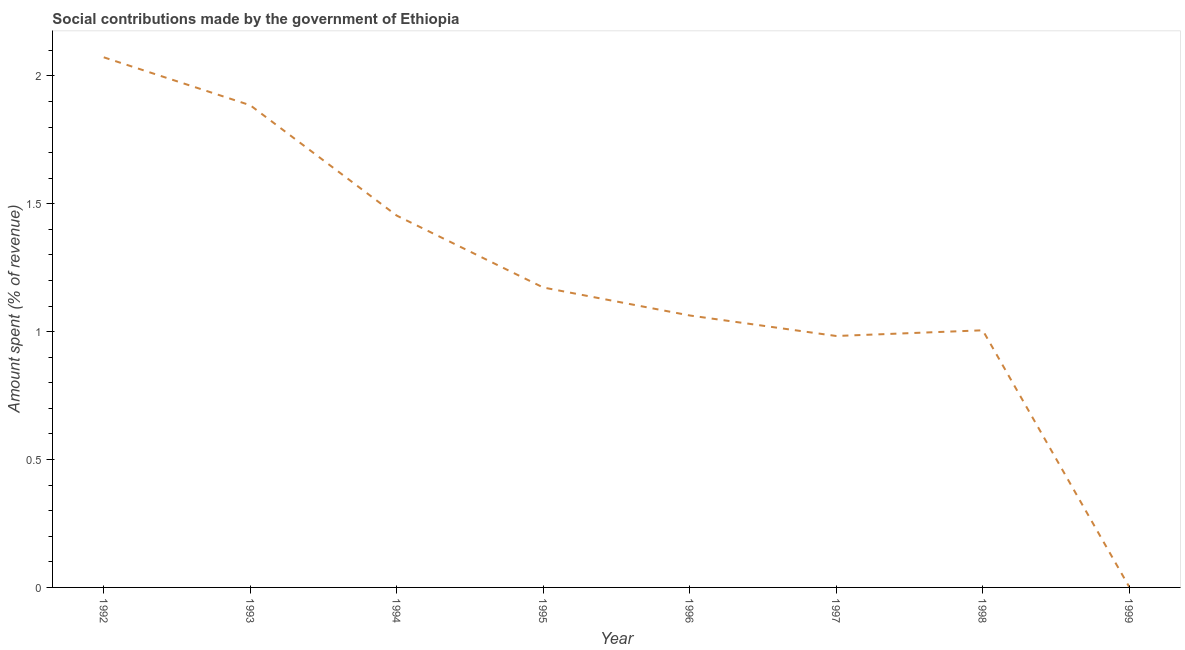What is the amount spent in making social contributions in 1993?
Offer a very short reply. 1.89. Across all years, what is the maximum amount spent in making social contributions?
Your response must be concise. 2.07. Across all years, what is the minimum amount spent in making social contributions?
Keep it short and to the point. 0. In which year was the amount spent in making social contributions minimum?
Make the answer very short. 1999. What is the sum of the amount spent in making social contributions?
Your response must be concise. 9.64. What is the difference between the amount spent in making social contributions in 1993 and 1999?
Your response must be concise. 1.88. What is the average amount spent in making social contributions per year?
Keep it short and to the point. 1.2. What is the median amount spent in making social contributions?
Your response must be concise. 1.12. Do a majority of the years between 1998 and 1995 (inclusive) have amount spent in making social contributions greater than 0.6 %?
Provide a succinct answer. Yes. What is the ratio of the amount spent in making social contributions in 1992 to that in 1993?
Ensure brevity in your answer.  1.1. Is the difference between the amount spent in making social contributions in 1992 and 1996 greater than the difference between any two years?
Ensure brevity in your answer.  No. What is the difference between the highest and the second highest amount spent in making social contributions?
Give a very brief answer. 0.19. Is the sum of the amount spent in making social contributions in 1992 and 1998 greater than the maximum amount spent in making social contributions across all years?
Keep it short and to the point. Yes. What is the difference between the highest and the lowest amount spent in making social contributions?
Offer a very short reply. 2.07. Does the amount spent in making social contributions monotonically increase over the years?
Keep it short and to the point. No. What is the difference between two consecutive major ticks on the Y-axis?
Provide a succinct answer. 0.5. Are the values on the major ticks of Y-axis written in scientific E-notation?
Offer a very short reply. No. Does the graph contain grids?
Your response must be concise. No. What is the title of the graph?
Your answer should be compact. Social contributions made by the government of Ethiopia. What is the label or title of the X-axis?
Give a very brief answer. Year. What is the label or title of the Y-axis?
Your answer should be compact. Amount spent (% of revenue). What is the Amount spent (% of revenue) in 1992?
Give a very brief answer. 2.07. What is the Amount spent (% of revenue) of 1993?
Provide a short and direct response. 1.89. What is the Amount spent (% of revenue) of 1994?
Your response must be concise. 1.45. What is the Amount spent (% of revenue) of 1995?
Your answer should be compact. 1.17. What is the Amount spent (% of revenue) of 1996?
Give a very brief answer. 1.06. What is the Amount spent (% of revenue) in 1997?
Ensure brevity in your answer.  0.98. What is the Amount spent (% of revenue) in 1998?
Offer a very short reply. 1.01. What is the Amount spent (% of revenue) of 1999?
Your response must be concise. 0. What is the difference between the Amount spent (% of revenue) in 1992 and 1993?
Your answer should be compact. 0.19. What is the difference between the Amount spent (% of revenue) in 1992 and 1994?
Offer a terse response. 0.62. What is the difference between the Amount spent (% of revenue) in 1992 and 1995?
Provide a succinct answer. 0.9. What is the difference between the Amount spent (% of revenue) in 1992 and 1996?
Your answer should be very brief. 1.01. What is the difference between the Amount spent (% of revenue) in 1992 and 1997?
Provide a succinct answer. 1.09. What is the difference between the Amount spent (% of revenue) in 1992 and 1998?
Offer a very short reply. 1.07. What is the difference between the Amount spent (% of revenue) in 1992 and 1999?
Your response must be concise. 2.07. What is the difference between the Amount spent (% of revenue) in 1993 and 1994?
Provide a short and direct response. 0.43. What is the difference between the Amount spent (% of revenue) in 1993 and 1995?
Your response must be concise. 0.71. What is the difference between the Amount spent (% of revenue) in 1993 and 1996?
Your answer should be very brief. 0.82. What is the difference between the Amount spent (% of revenue) in 1993 and 1997?
Ensure brevity in your answer.  0.9. What is the difference between the Amount spent (% of revenue) in 1993 and 1998?
Your answer should be compact. 0.88. What is the difference between the Amount spent (% of revenue) in 1993 and 1999?
Your answer should be compact. 1.88. What is the difference between the Amount spent (% of revenue) in 1994 and 1995?
Ensure brevity in your answer.  0.28. What is the difference between the Amount spent (% of revenue) in 1994 and 1996?
Provide a succinct answer. 0.39. What is the difference between the Amount spent (% of revenue) in 1994 and 1997?
Provide a succinct answer. 0.47. What is the difference between the Amount spent (% of revenue) in 1994 and 1998?
Give a very brief answer. 0.45. What is the difference between the Amount spent (% of revenue) in 1994 and 1999?
Make the answer very short. 1.45. What is the difference between the Amount spent (% of revenue) in 1995 and 1996?
Your answer should be very brief. 0.11. What is the difference between the Amount spent (% of revenue) in 1995 and 1997?
Your answer should be compact. 0.19. What is the difference between the Amount spent (% of revenue) in 1995 and 1998?
Make the answer very short. 0.17. What is the difference between the Amount spent (% of revenue) in 1995 and 1999?
Provide a succinct answer. 1.17. What is the difference between the Amount spent (% of revenue) in 1996 and 1997?
Offer a terse response. 0.08. What is the difference between the Amount spent (% of revenue) in 1996 and 1998?
Give a very brief answer. 0.06. What is the difference between the Amount spent (% of revenue) in 1996 and 1999?
Offer a terse response. 1.06. What is the difference between the Amount spent (% of revenue) in 1997 and 1998?
Give a very brief answer. -0.02. What is the difference between the Amount spent (% of revenue) in 1997 and 1999?
Your response must be concise. 0.98. What is the difference between the Amount spent (% of revenue) in 1998 and 1999?
Provide a short and direct response. 1. What is the ratio of the Amount spent (% of revenue) in 1992 to that in 1993?
Provide a short and direct response. 1.1. What is the ratio of the Amount spent (% of revenue) in 1992 to that in 1994?
Provide a succinct answer. 1.43. What is the ratio of the Amount spent (% of revenue) in 1992 to that in 1995?
Your answer should be very brief. 1.77. What is the ratio of the Amount spent (% of revenue) in 1992 to that in 1996?
Provide a short and direct response. 1.95. What is the ratio of the Amount spent (% of revenue) in 1992 to that in 1997?
Ensure brevity in your answer.  2.11. What is the ratio of the Amount spent (% of revenue) in 1992 to that in 1998?
Give a very brief answer. 2.06. What is the ratio of the Amount spent (% of revenue) in 1992 to that in 1999?
Provide a succinct answer. 1005.96. What is the ratio of the Amount spent (% of revenue) in 1993 to that in 1994?
Provide a succinct answer. 1.3. What is the ratio of the Amount spent (% of revenue) in 1993 to that in 1995?
Provide a succinct answer. 1.61. What is the ratio of the Amount spent (% of revenue) in 1993 to that in 1996?
Give a very brief answer. 1.77. What is the ratio of the Amount spent (% of revenue) in 1993 to that in 1997?
Make the answer very short. 1.92. What is the ratio of the Amount spent (% of revenue) in 1993 to that in 1998?
Your answer should be very brief. 1.88. What is the ratio of the Amount spent (% of revenue) in 1993 to that in 1999?
Provide a succinct answer. 914.98. What is the ratio of the Amount spent (% of revenue) in 1994 to that in 1995?
Provide a short and direct response. 1.24. What is the ratio of the Amount spent (% of revenue) in 1994 to that in 1996?
Keep it short and to the point. 1.37. What is the ratio of the Amount spent (% of revenue) in 1994 to that in 1997?
Your answer should be very brief. 1.48. What is the ratio of the Amount spent (% of revenue) in 1994 to that in 1998?
Offer a terse response. 1.45. What is the ratio of the Amount spent (% of revenue) in 1994 to that in 1999?
Offer a very short reply. 705.57. What is the ratio of the Amount spent (% of revenue) in 1995 to that in 1996?
Make the answer very short. 1.1. What is the ratio of the Amount spent (% of revenue) in 1995 to that in 1997?
Provide a succinct answer. 1.19. What is the ratio of the Amount spent (% of revenue) in 1995 to that in 1998?
Give a very brief answer. 1.17. What is the ratio of the Amount spent (% of revenue) in 1995 to that in 1999?
Your response must be concise. 569.13. What is the ratio of the Amount spent (% of revenue) in 1996 to that in 1997?
Provide a short and direct response. 1.08. What is the ratio of the Amount spent (% of revenue) in 1996 to that in 1998?
Your answer should be very brief. 1.06. What is the ratio of the Amount spent (% of revenue) in 1996 to that in 1999?
Keep it short and to the point. 516.04. What is the ratio of the Amount spent (% of revenue) in 1997 to that in 1998?
Your answer should be compact. 0.98. What is the ratio of the Amount spent (% of revenue) in 1997 to that in 1999?
Provide a succinct answer. 477.13. What is the ratio of the Amount spent (% of revenue) in 1998 to that in 1999?
Ensure brevity in your answer.  487.93. 